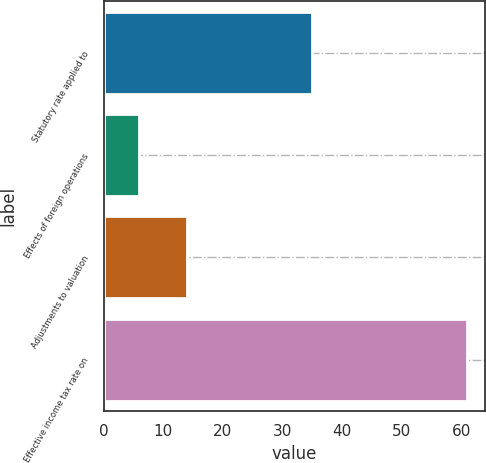Convert chart. <chart><loc_0><loc_0><loc_500><loc_500><bar_chart><fcel>Statutory rate applied to<fcel>Effects of foreign operations<fcel>Adjustments to valuation<fcel>Effective income tax rate on<nl><fcel>35<fcel>6<fcel>14<fcel>61<nl></chart> 